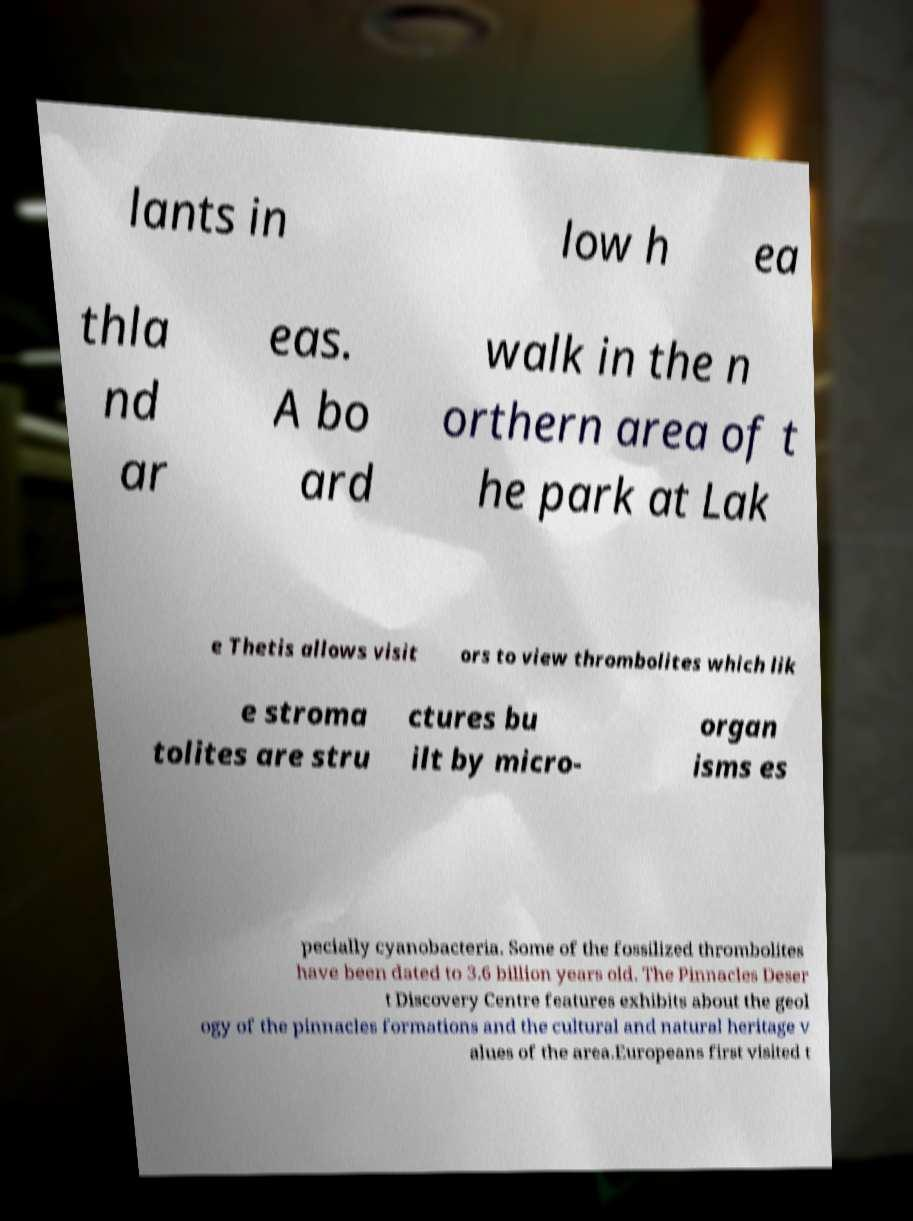There's text embedded in this image that I need extracted. Can you transcribe it verbatim? lants in low h ea thla nd ar eas. A bo ard walk in the n orthern area of t he park at Lak e Thetis allows visit ors to view thrombolites which lik e stroma tolites are stru ctures bu ilt by micro- organ isms es pecially cyanobacteria. Some of the fossilized thrombolites have been dated to 3.6 billion years old. The Pinnacles Deser t Discovery Centre features exhibits about the geol ogy of the pinnacles formations and the cultural and natural heritage v alues of the area.Europeans first visited t 